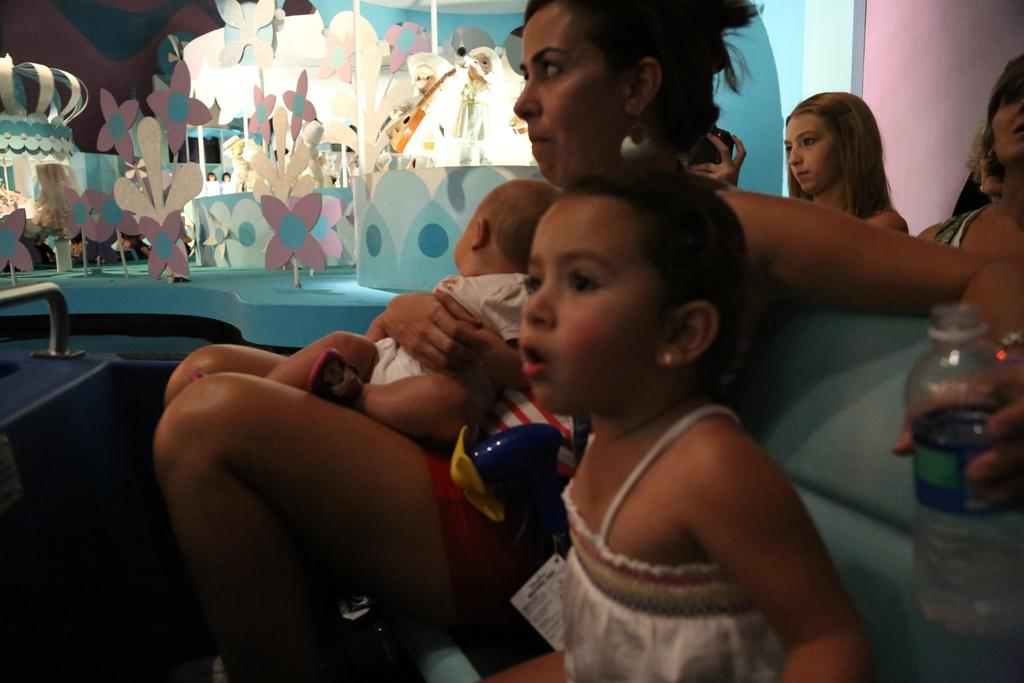What are the people in the image doing? The people in the image are sitting on chairs or sofas. Can you describe what the woman is holding in her hand? The woman is holding a water bottle in her hand. What else can be seen in the image besides people sitting? There are toys and a flower statue in the image. Where are the toys and flower statue located? The toys and flower statue are kept on a stage. What type of mountain can be seen in the background of the image? There is no mountain visible in the image. 